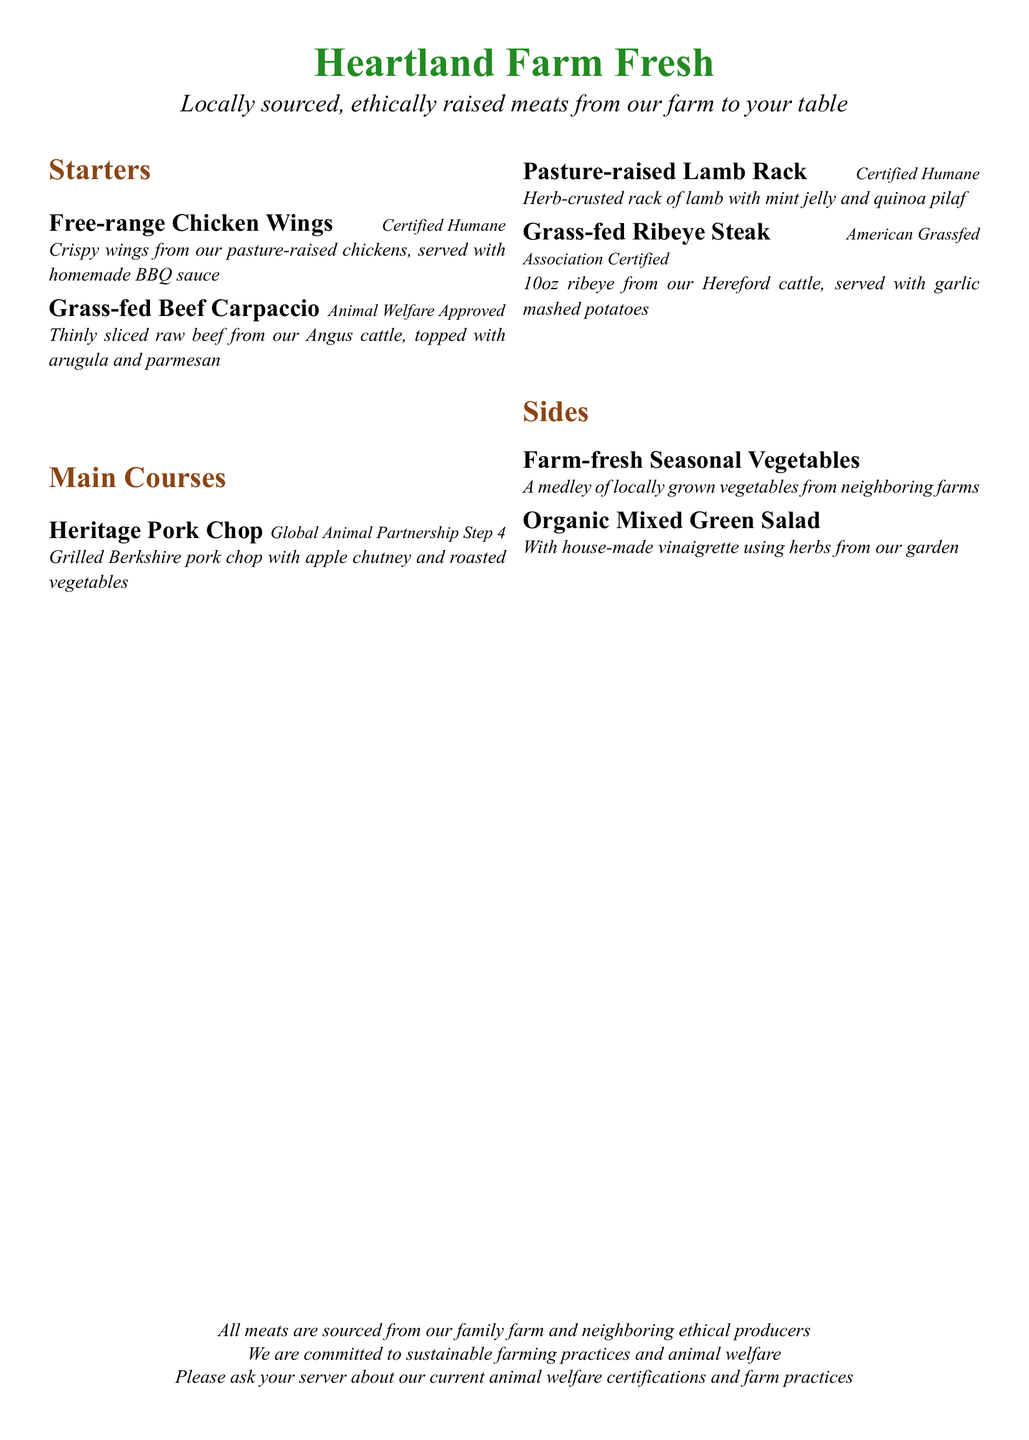What is the name of the restaurant? The title at the top of the menu identifies the name of the restaurant, which is "Heartland Farm Fresh."
Answer: Heartland Farm Fresh What type of meats does the restaurant feature? The description mentions that the restaurant features meats that are "locally sourced, ethically raised."
Answer: Locally sourced, ethically raised What is served with the free-range chicken wings? The menu item lists "homemade BBQ sauce" as the accompaniment to the chicken wings.
Answer: Homemade BBQ sauce How many ounces is the ribeye steak? The menu specifies that the ribeye steak is "10oz."
Answer: 10oz What animal welfare certification is associated with the pasture-raised lamb rack? The menu item states that the lamb rack is "Certified Humane."
Answer: Certified Humane What is the name of the side salad? The menu item lists "Organic Mixed Green Salad" as one of the sides offered.
Answer: Organic Mixed Green Salad Which meat comes from Angus cattle? The menu specifies that the "Grass-fed Beef Carpaccio" is made from Angus cattle.
Answer: Grass-fed Beef Carpaccio How is the heritage pork chop prepared? The menu indicates that the pork chop is "Grilled" and comes with "apple chutney and roasted vegetables."
Answer: Grilled Which certification is associated with grass-fed ribeye steak? The menu mentions "American Grassfed Association Certified" for the ribeye steak.
Answer: American Grassfed Association Certified 